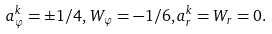Convert formula to latex. <formula><loc_0><loc_0><loc_500><loc_500>a _ { \varphi } ^ { k } = \pm 1 / 4 , \, W _ { \varphi } = - 1 / 6 , a ^ { k } _ { r } = W _ { r } = 0 .</formula> 